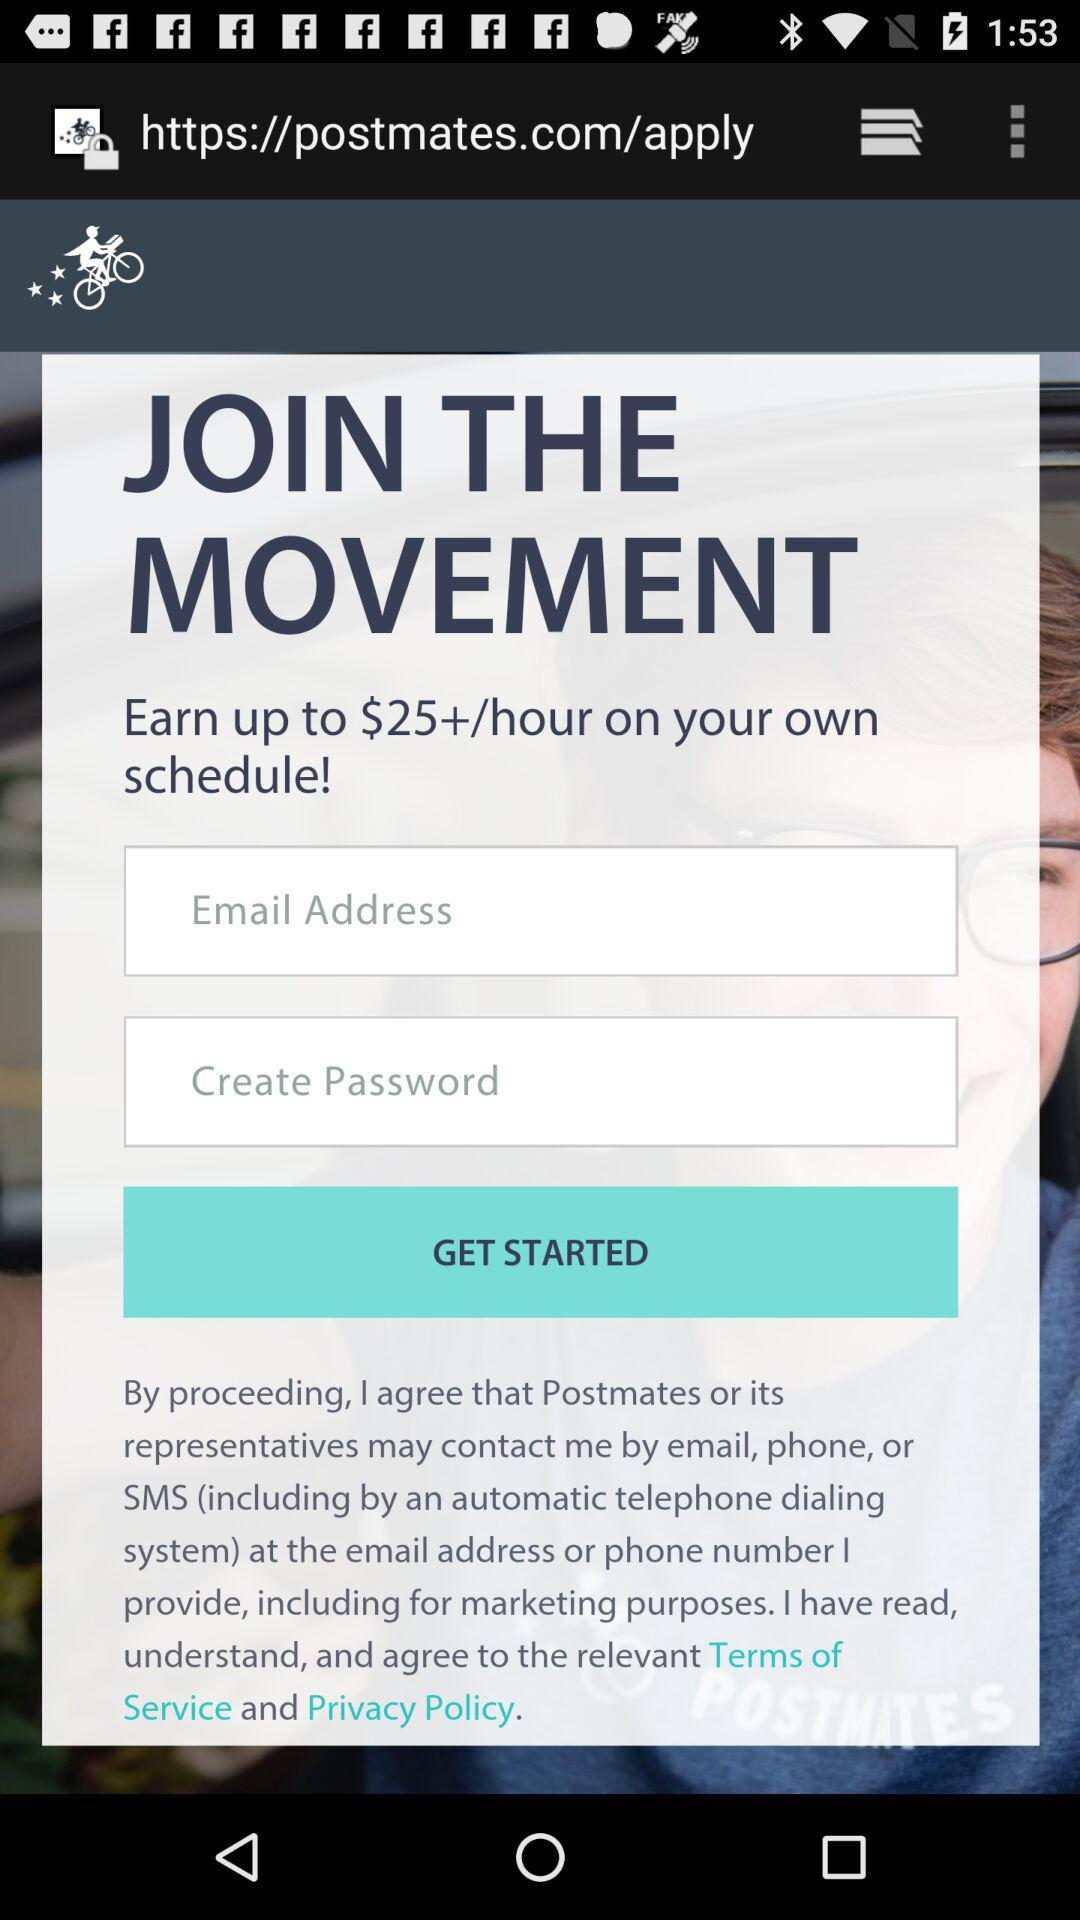How much can we earn per hour? You can earn up to more than $25 per hour. 